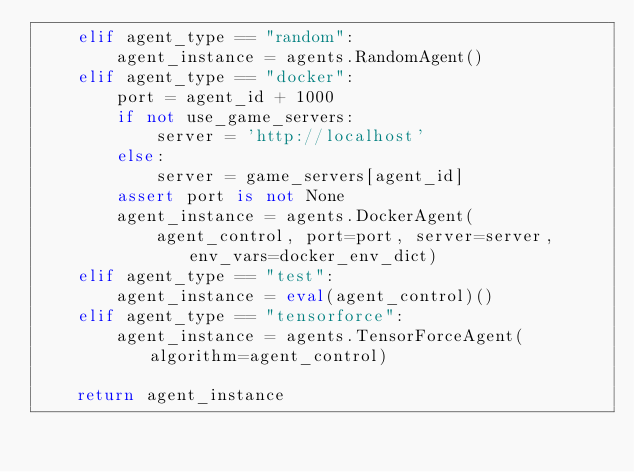<code> <loc_0><loc_0><loc_500><loc_500><_Python_>    elif agent_type == "random":
        agent_instance = agents.RandomAgent()
    elif agent_type == "docker":
        port = agent_id + 1000
        if not use_game_servers:
            server = 'http://localhost'
        else:
            server = game_servers[agent_id]
        assert port is not None
        agent_instance = agents.DockerAgent(
            agent_control, port=port, server=server, env_vars=docker_env_dict)
    elif agent_type == "test":
        agent_instance = eval(agent_control)()
    elif agent_type == "tensorforce":
        agent_instance = agents.TensorForceAgent(algorithm=agent_control)

    return agent_instance
</code> 